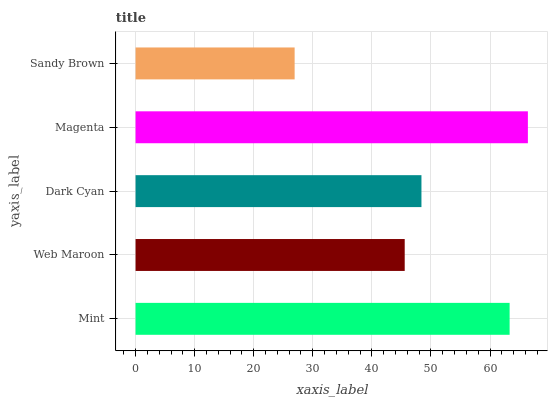Is Sandy Brown the minimum?
Answer yes or no. Yes. Is Magenta the maximum?
Answer yes or no. Yes. Is Web Maroon the minimum?
Answer yes or no. No. Is Web Maroon the maximum?
Answer yes or no. No. Is Mint greater than Web Maroon?
Answer yes or no. Yes. Is Web Maroon less than Mint?
Answer yes or no. Yes. Is Web Maroon greater than Mint?
Answer yes or no. No. Is Mint less than Web Maroon?
Answer yes or no. No. Is Dark Cyan the high median?
Answer yes or no. Yes. Is Dark Cyan the low median?
Answer yes or no. Yes. Is Web Maroon the high median?
Answer yes or no. No. Is Mint the low median?
Answer yes or no. No. 